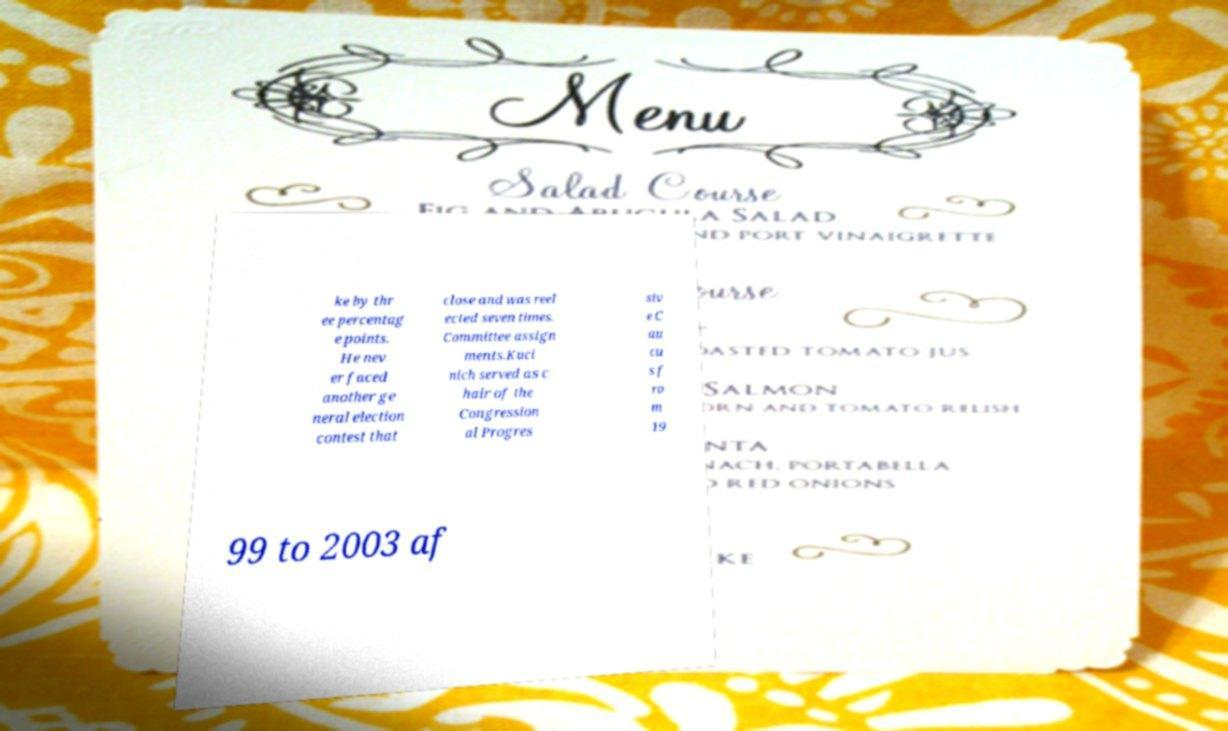Please identify and transcribe the text found in this image. ke by thr ee percentag e points. He nev er faced another ge neral election contest that close and was reel ected seven times. Committee assign ments.Kuci nich served as c hair of the Congression al Progres siv e C au cu s f ro m 19 99 to 2003 af 